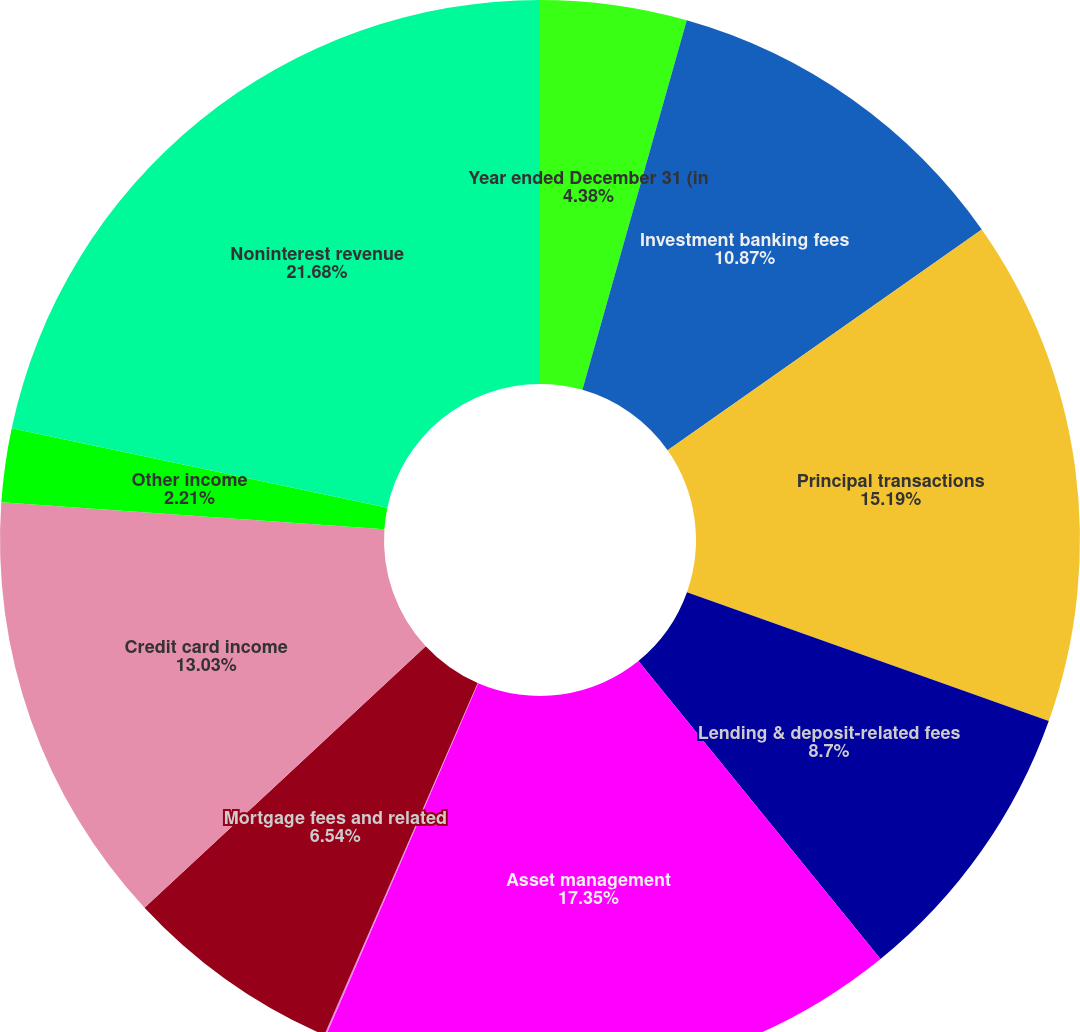Convert chart to OTSL. <chart><loc_0><loc_0><loc_500><loc_500><pie_chart><fcel>Year ended December 31 (in<fcel>Investment banking fees<fcel>Principal transactions<fcel>Lending & deposit-related fees<fcel>Asset management<fcel>Securities gains (losses)<fcel>Mortgage fees and related<fcel>Credit card income<fcel>Other income<fcel>Noninterest revenue<nl><fcel>4.38%<fcel>10.87%<fcel>15.19%<fcel>8.7%<fcel>17.35%<fcel>0.05%<fcel>6.54%<fcel>13.03%<fcel>2.21%<fcel>21.68%<nl></chart> 